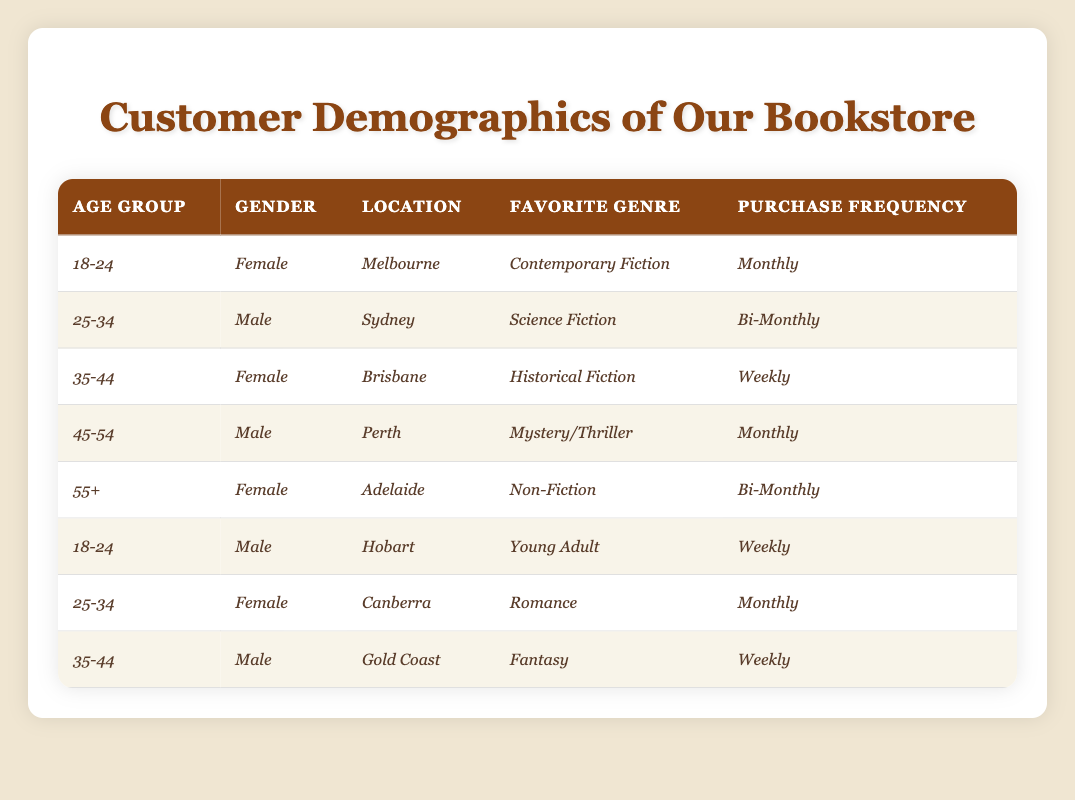What is the favorite genre of the youngest age group? The youngest age group is *18-24*. In the table, there are two entries for this age group: one for a Female from Melbourne, whose favorite genre is *Contemporary Fiction*, and another for a Male from Hobart, whose favorite genre is *Young Adult*. Therefore, the favorite genres are *Contemporary Fiction* and *Young Adult*.
Answer: *Contemporary Fiction* and *Young Adult* How many female customers are in the age group 35-44? In the table, there is one female customer in the age group *35-44* from Brisbane with a favorite genre of *Historical Fiction*.
Answer: 1 Are there any customers from Adelaide who purchase books weekly? In the table, there is a Female from Adelaide in the age group *55+*, purchasing books *Bi-Monthly*, and no other entry from Adelaide with a weekly purchasing frequency. Therefore, there are no customers from Adelaide who purchase books weekly.
Answer: No What is the most common purchase frequency among customers? To find the most common purchase frequency, we can count each entry: *Monthly* occurs 3 times, *Bi-Monthly* occurs 3 times, and *Weekly* occurs 3 times. Therefore, *Monthly*, *Bi-Monthly*, and *Weekly* are all equally common.
Answer: *Monthly*, *Bi-Monthly*, and *Weekly* Which age group has the highest frequency of purchases? The age groups with the highest purchase frequency are *35-44* (Female, Weekly), *18-24* (Male, Weekly), and *35-44* (Male, Weekly). Since these age groups have customers who purchase weekly, they share the highest frequency of purchases with *Weekly* being the value.
Answer: *35-44* and *18-24* How many male customers there are in the *25-34* age group? In the table, there is one male customer aged *25-34* from Sydney with a favorite genre of *Science Fiction*. Therefore, the count of male customers in that age group is 1.
Answer: 1 What is the average age group for customers who favor *Fantasy* genre? The only customer favoring *Fantasy* is a Male in the age group *35-44* from Gold Coast. Since there's only one data point, the average is simply the age group of that entry, which is *35-44*.
Answer: *35-44* How many customers have a purchase frequency of *Monthly* and what are their favorite genres? There are three customers with a purchase frequency of *Monthly*: one Female aged *18-24* from Melbourne (favorite genre: *Contemporary Fiction*), one Male aged *45-54* from Perth (favorite genre: *Mystery/Thriller*), and one Female aged *25-34* from Canberra (favorite genre: *Romance*).
Answer: 3 customers: *Contemporary Fiction*, *Mystery/Thriller*, and *Romance* Is there a female customer in the age group *55+*? There is one entry for a customer aged *55+*, who is a Female from Adelaide, whose favorite genre is *Non-Fiction*. Thus, there is indeed a female customer in this age group.
Answer: Yes Which location has the highest concentration of customers in the age range of *25-34*? For the *25-34* age group, there are two entries: one Male from Sydney and one Female from Canberra, making it two different locations. Therefore, there is no high concentration, as both have equal frequency (1 each).
Answer: No clear highest concentration What is the total number of customers across all age groups? There are a total of 8 entries in the table, representing 8 unique customers.
Answer: 8 